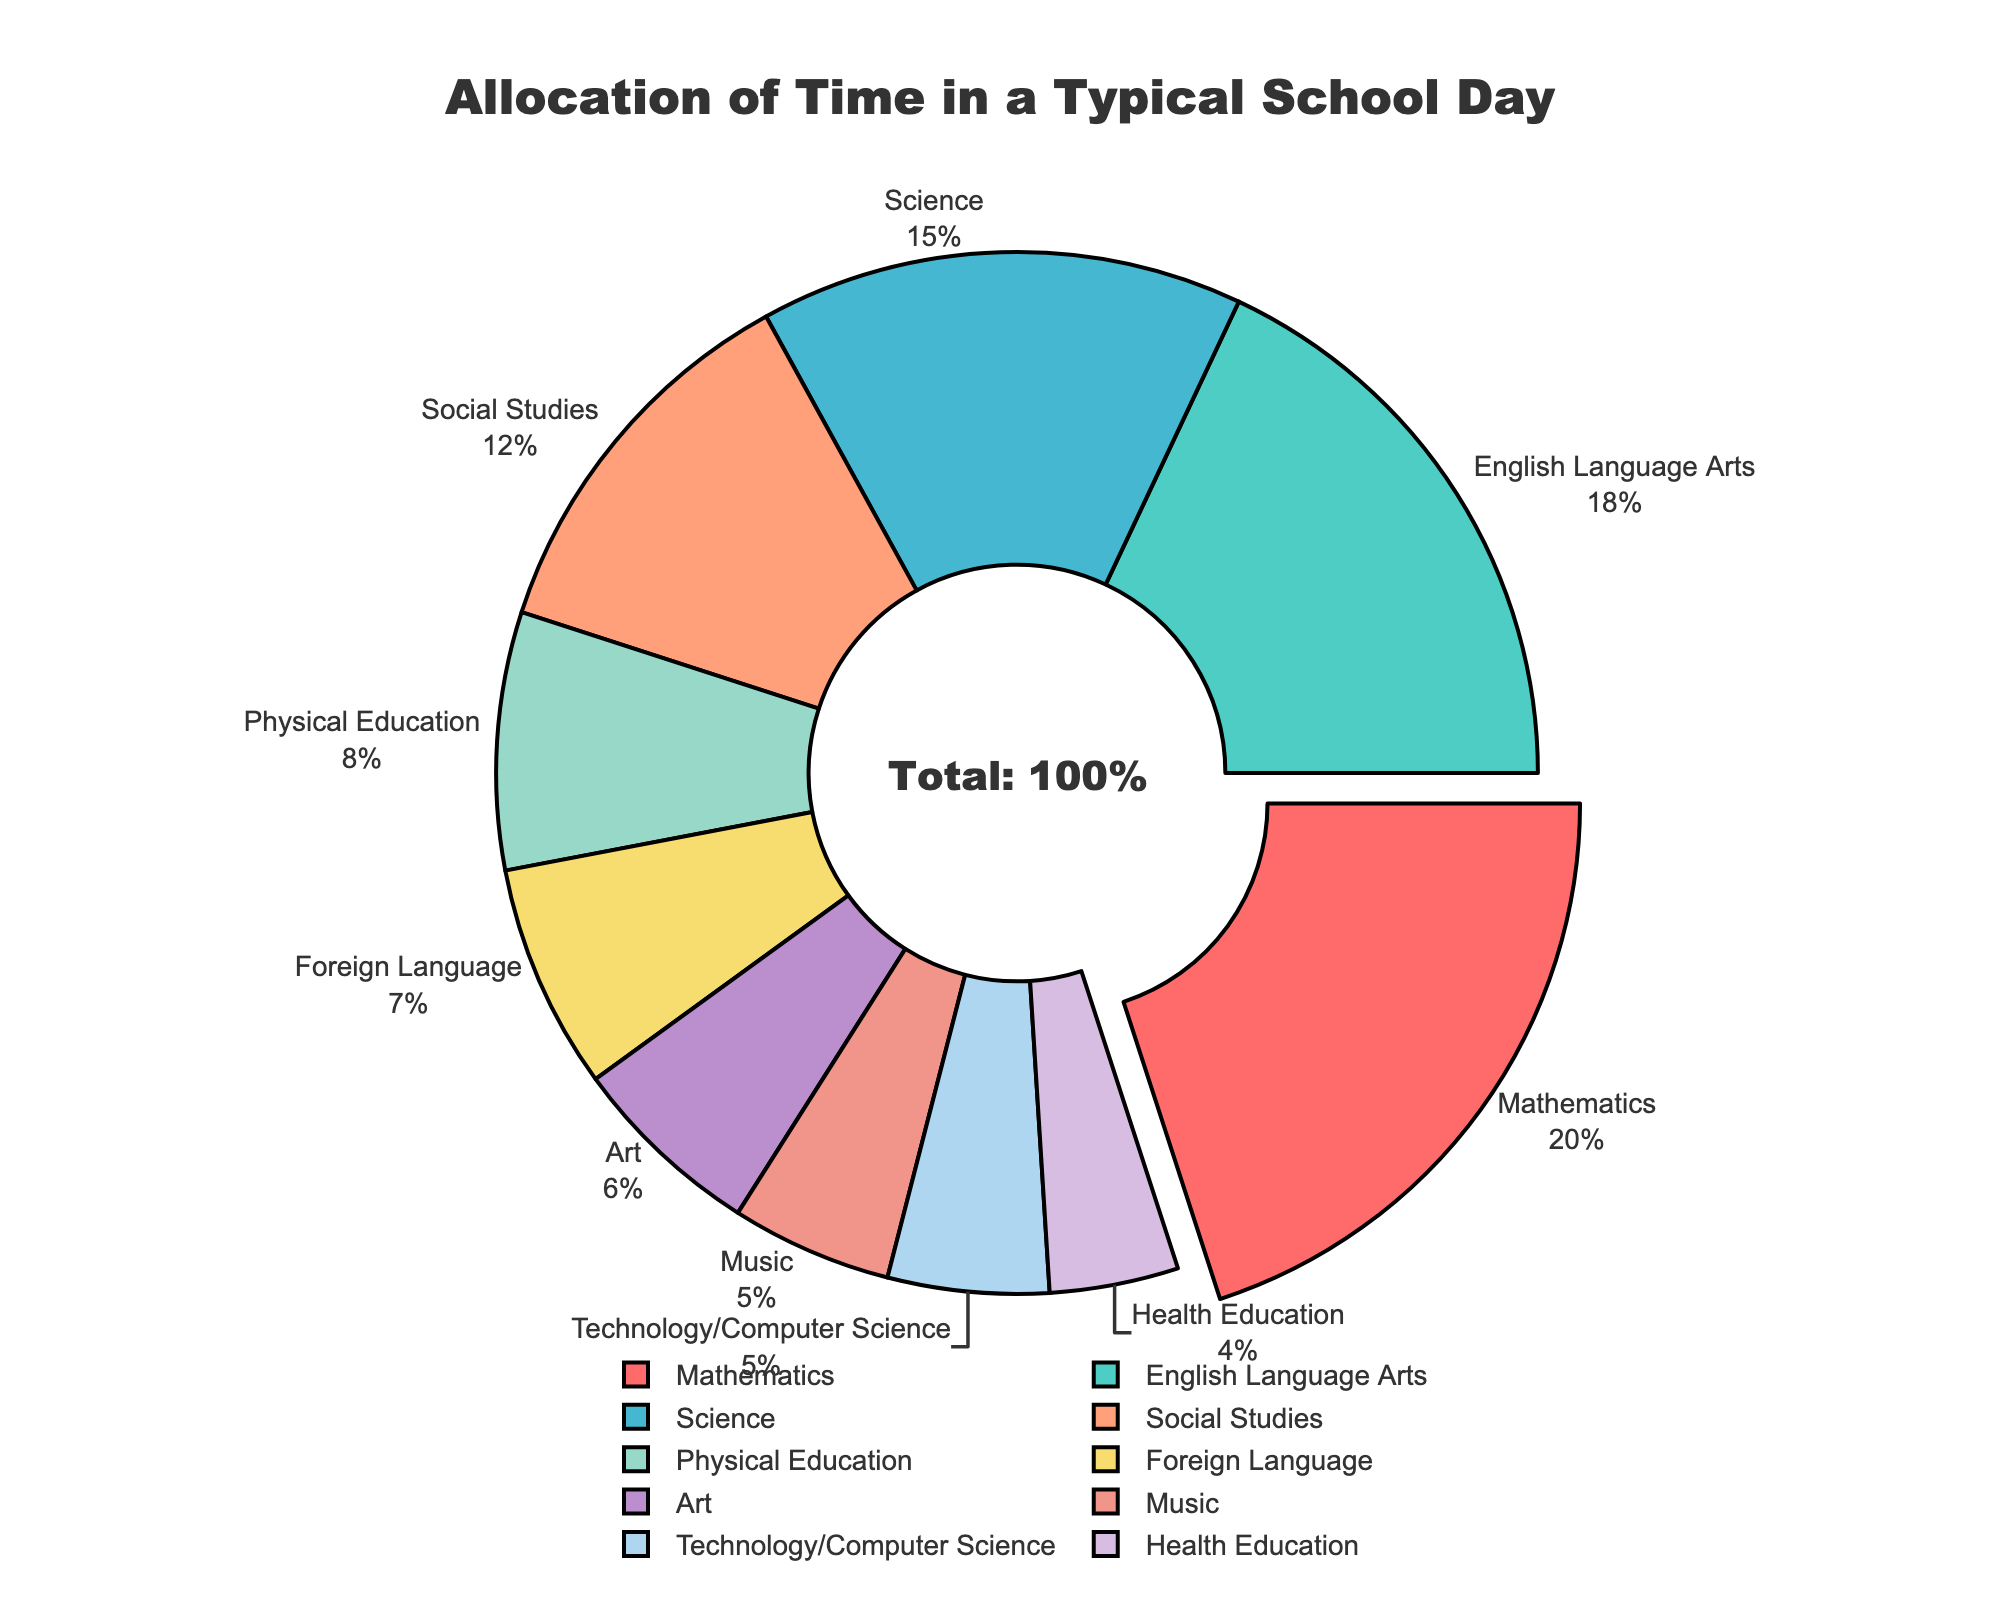What's the subject with the highest percentage of time allocation in a typical school day? The subject with the highest percentage is shown as the largest segment in the pie chart and often has its section pulled out for emphasis. According to the chart, Mathematics holds the largest percentage of 20%.
Answer: Mathematics Which subjects have less than 10% of time allocation? To find this information, look at the segments with time allocations less than 10% in the chart. Those segments include Physical Education (8%), Foreign Language (7%), Art (6%), Music (5%), Technology/Computer Science (5%), and Health Education (4%).
Answer: Physical Education, Foreign Language, Art, Music, Technology/Computer Science, Health Education How much more time is allocated to Mathematics compared to Music? Subtract the percentage of time allocated to Music from that of Mathematics. Mathematics has 20%, and Music has 5%. So, 20% - 5% = 15%.
Answer: 15% What is the combined time allocation for Science and Social Studies? Add the percentages for Science (15%) and Social Studies (12%). So, 15% + 12% = 27%.
Answer: 27% Compare the time allocations of English Language Arts and Foreign Language. Which one is greater and by how much? English Language Arts has 18% while Foreign Language has 7%. To find the difference, subtract 7% from 18%, which is 18% - 7% = 11%. Thus, English Language Arts has 11% more time allocated than Foreign Language.
Answer: English Language Arts by 11% What percentage of total time is allocated to non-academic subjects (Physical Education, Art, Music, Technology/Computer Science, and Health Education)? Sum the percentages for non-academic subjects: Physical Education (8%), Art (6%), Music (5%), Technology/Computer Science (5%), and Health Education (4%). Adding these gives 8% + 6% + 5% + 5% + 4% = 28%.
Answer: 28% What is the difference between the highest and lowest time allocations for a subject? The highest allocation is Mathematics at 20%, and the lowest is Health Education at 4%. Subtract 4% from 20%, which is 20% - 4% = 16%.
Answer: 16% List the subjects that have more than 10% but less than 20% time allocation. The pie chart shows subjects with their corresponding percentages. Subjects with time allocations greater than 10% but less than 20% are English Language Arts (18%), Science (15%), and Social Studies (12%).
Answer: English Language Arts, Science, Social Studies 